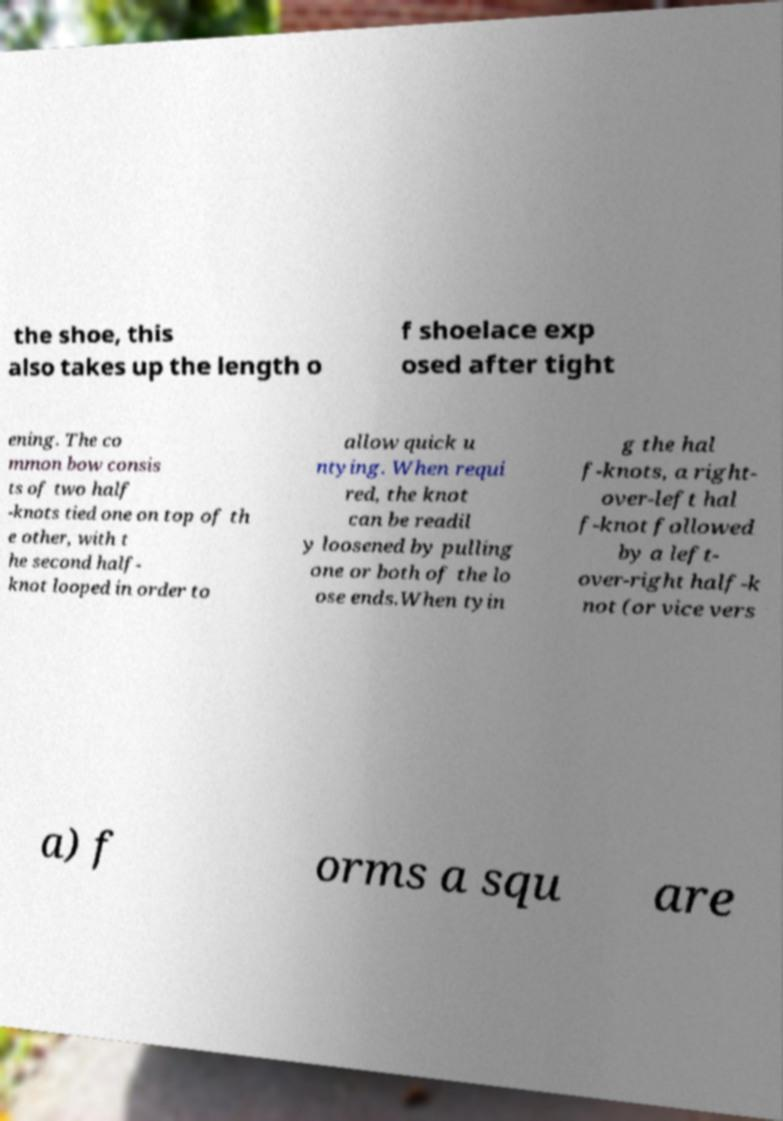Can you accurately transcribe the text from the provided image for me? the shoe, this also takes up the length o f shoelace exp osed after tight ening. The co mmon bow consis ts of two half -knots tied one on top of th e other, with t he second half- knot looped in order to allow quick u ntying. When requi red, the knot can be readil y loosened by pulling one or both of the lo ose ends.When tyin g the hal f-knots, a right- over-left hal f-knot followed by a left- over-right half-k not (or vice vers a) f orms a squ are 